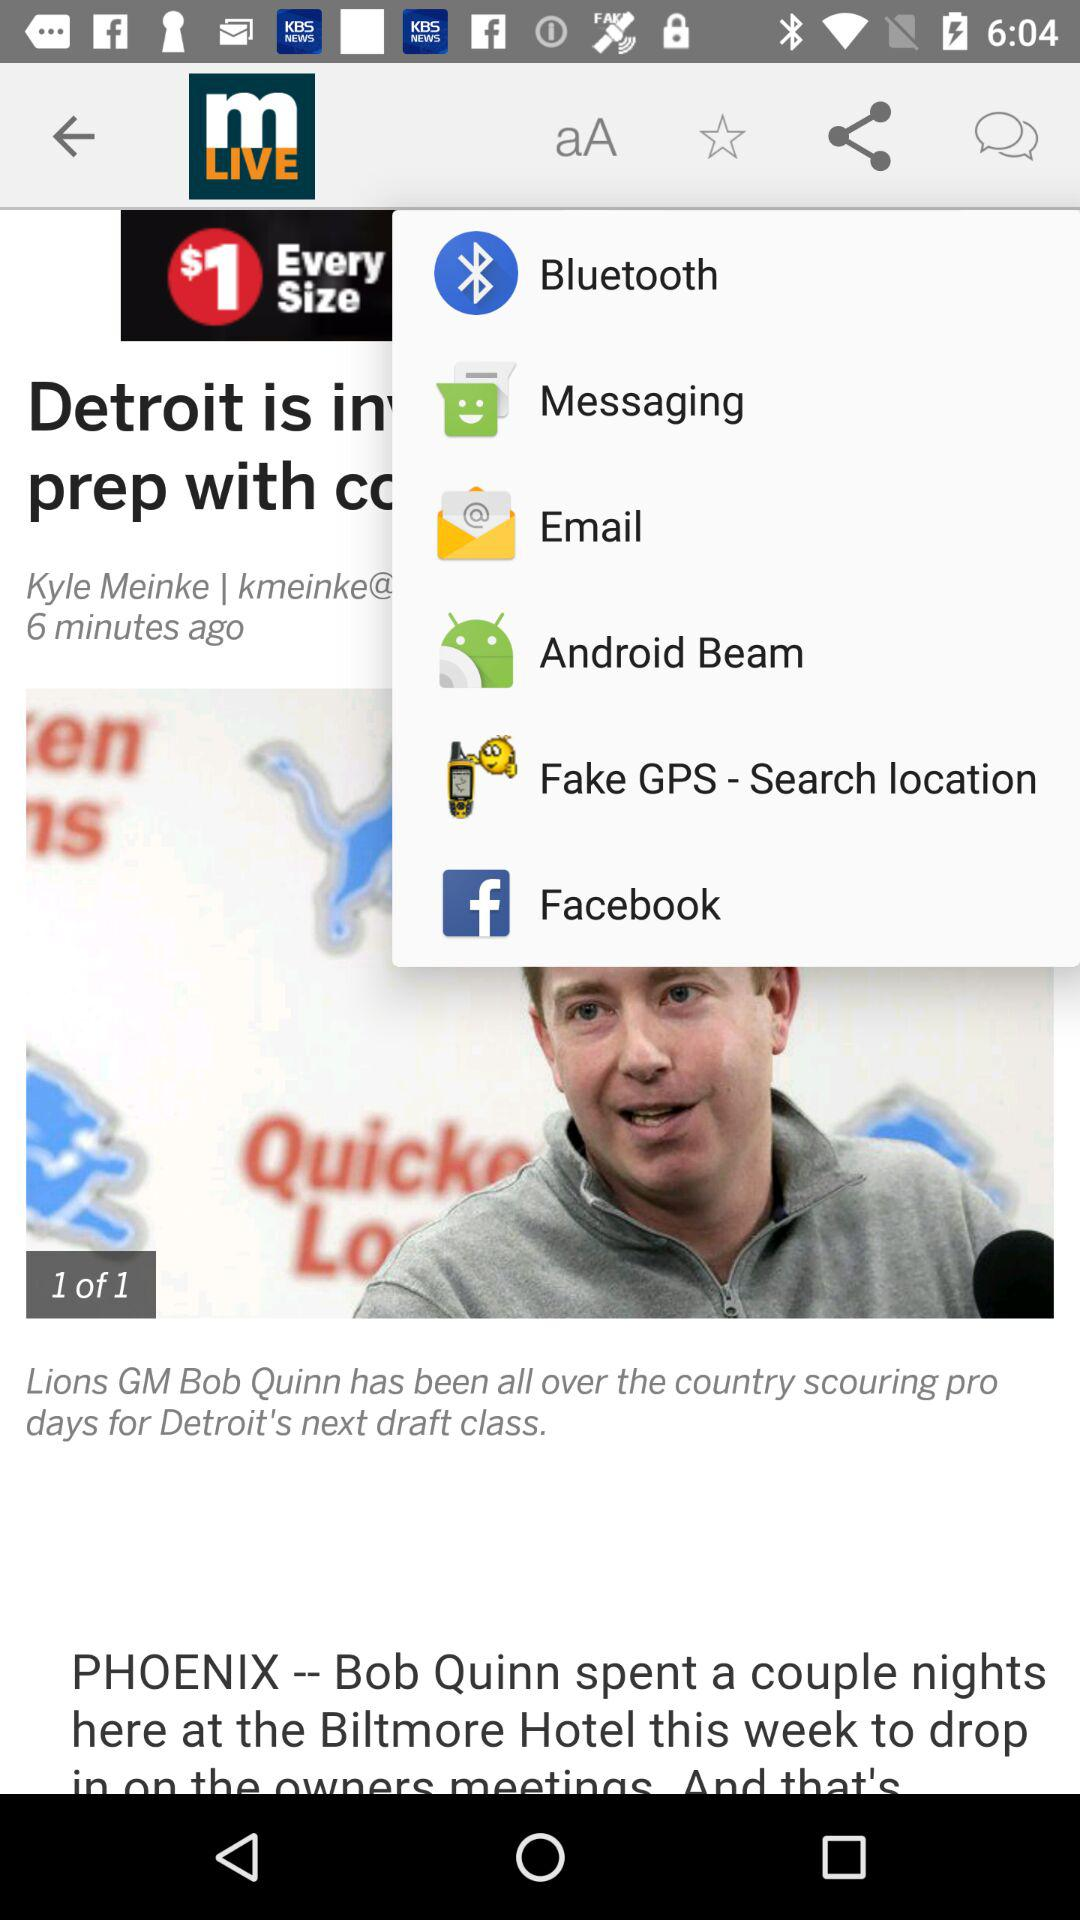How many images in total are there? There is one image in total. 